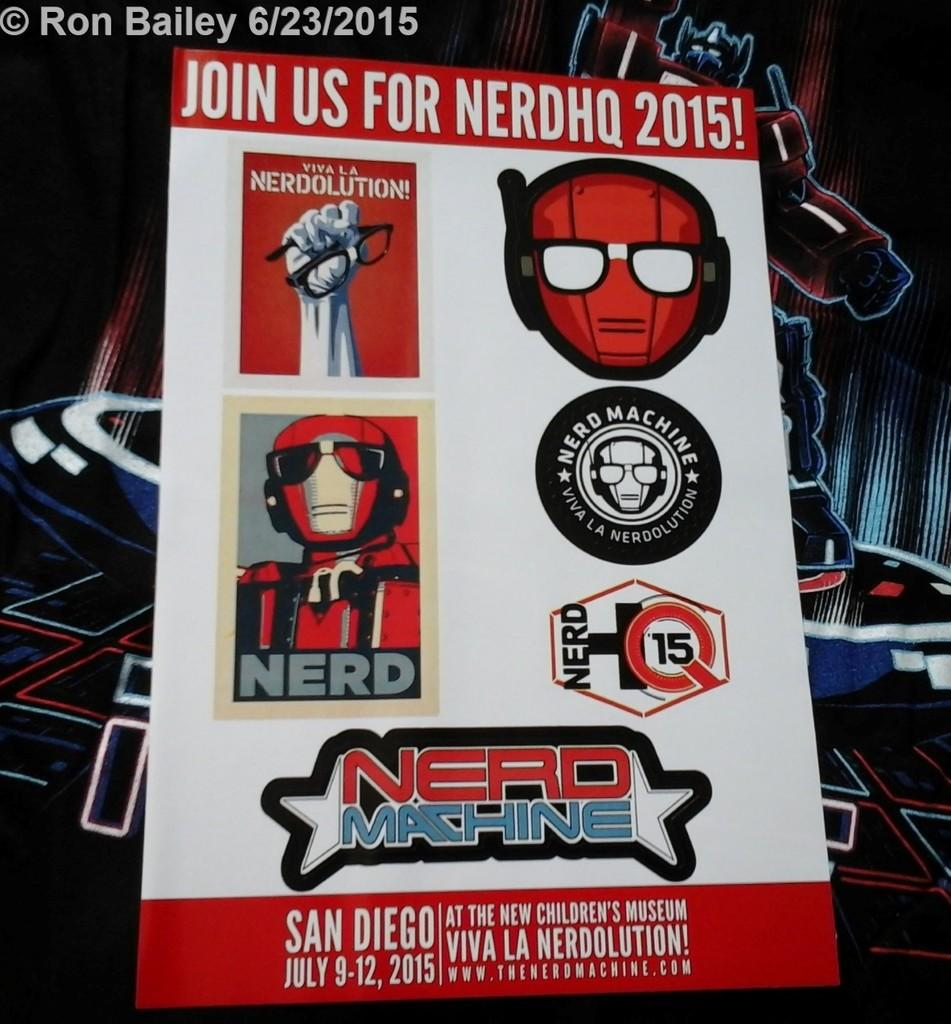<image>
Render a clear and concise summary of the photo. A card advertising "NerdHQ 2015" is shown with different logos about nerds. 